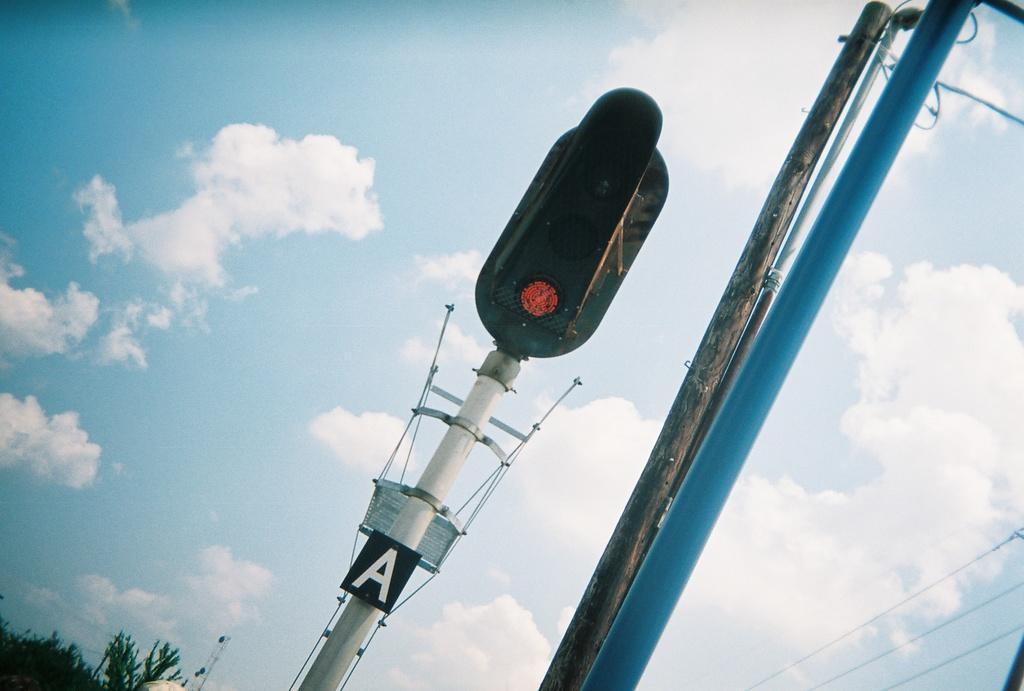What is the main object in the middle of the image? There is a signal light in the middle of the image. What else can be seen beside the signal light? There are two poles beside the signal light. What is visible at the top of the image? The sky is visible at the top of the image. What type of vegetation is on the left side of the image? There are plants on the left side of the image. What type of paper is the mother holding in the image? There is no mother or paper present in the image. What type of lock is used to secure the signal light in the image? There is no lock present in the image; the signal light is not secured with a lock. 